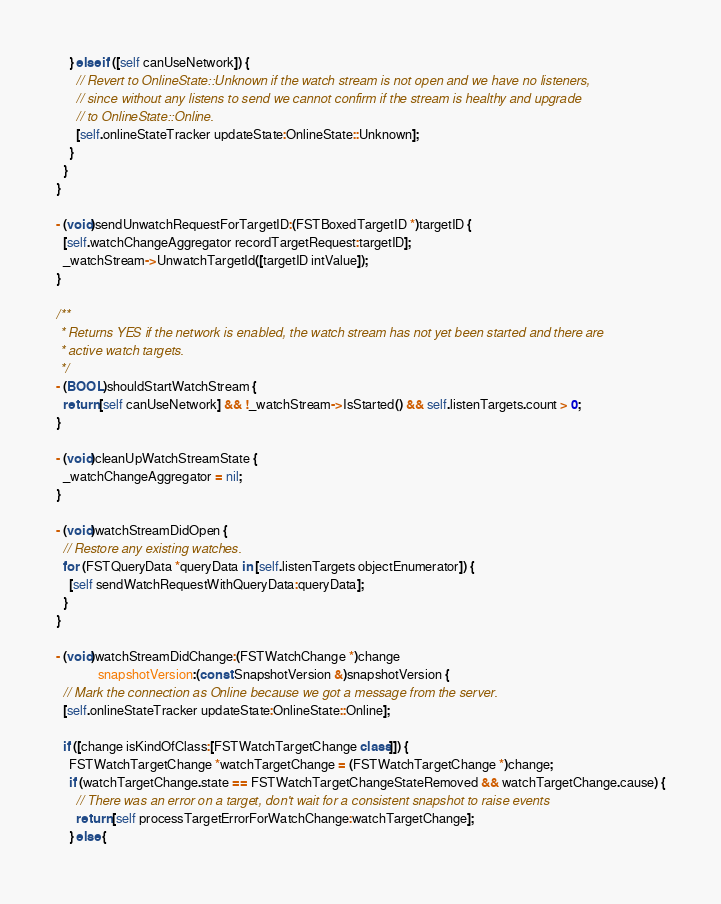<code> <loc_0><loc_0><loc_500><loc_500><_ObjectiveC_>    } else if ([self canUseNetwork]) {
      // Revert to OnlineState::Unknown if the watch stream is not open and we have no listeners,
      // since without any listens to send we cannot confirm if the stream is healthy and upgrade
      // to OnlineState::Online.
      [self.onlineStateTracker updateState:OnlineState::Unknown];
    }
  }
}

- (void)sendUnwatchRequestForTargetID:(FSTBoxedTargetID *)targetID {
  [self.watchChangeAggregator recordTargetRequest:targetID];
  _watchStream->UnwatchTargetId([targetID intValue]);
}

/**
 * Returns YES if the network is enabled, the watch stream has not yet been started and there are
 * active watch targets.
 */
- (BOOL)shouldStartWatchStream {
  return [self canUseNetwork] && !_watchStream->IsStarted() && self.listenTargets.count > 0;
}

- (void)cleanUpWatchStreamState {
  _watchChangeAggregator = nil;
}

- (void)watchStreamDidOpen {
  // Restore any existing watches.
  for (FSTQueryData *queryData in [self.listenTargets objectEnumerator]) {
    [self sendWatchRequestWithQueryData:queryData];
  }
}

- (void)watchStreamDidChange:(FSTWatchChange *)change
             snapshotVersion:(const SnapshotVersion &)snapshotVersion {
  // Mark the connection as Online because we got a message from the server.
  [self.onlineStateTracker updateState:OnlineState::Online];

  if ([change isKindOfClass:[FSTWatchTargetChange class]]) {
    FSTWatchTargetChange *watchTargetChange = (FSTWatchTargetChange *)change;
    if (watchTargetChange.state == FSTWatchTargetChangeStateRemoved && watchTargetChange.cause) {
      // There was an error on a target, don't wait for a consistent snapshot to raise events
      return [self processTargetErrorForWatchChange:watchTargetChange];
    } else {</code> 